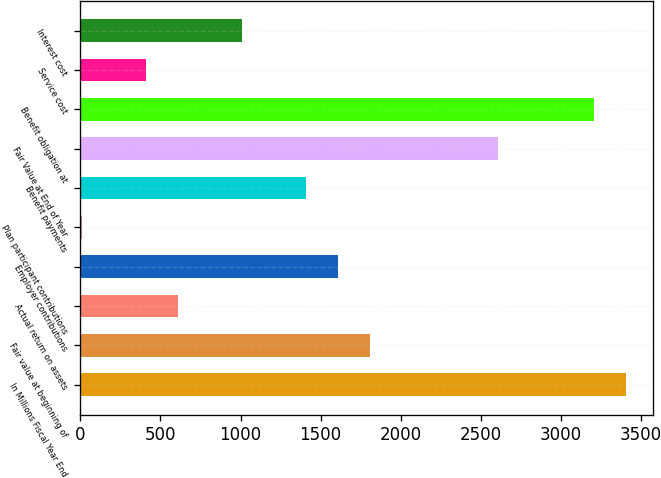<chart> <loc_0><loc_0><loc_500><loc_500><bar_chart><fcel>In Millions Fiscal Year End<fcel>Fair value at beginning of<fcel>Actual return on assets<fcel>Employer contributions<fcel>Plan participant contributions<fcel>Benefit payments<fcel>Fair Value at End of Year<fcel>Benefit obligation at<fcel>Service cost<fcel>Interest cost<nl><fcel>3403.9<fcel>1806.3<fcel>608.1<fcel>1606.6<fcel>9<fcel>1406.9<fcel>2605.1<fcel>3204.2<fcel>408.4<fcel>1007.5<nl></chart> 